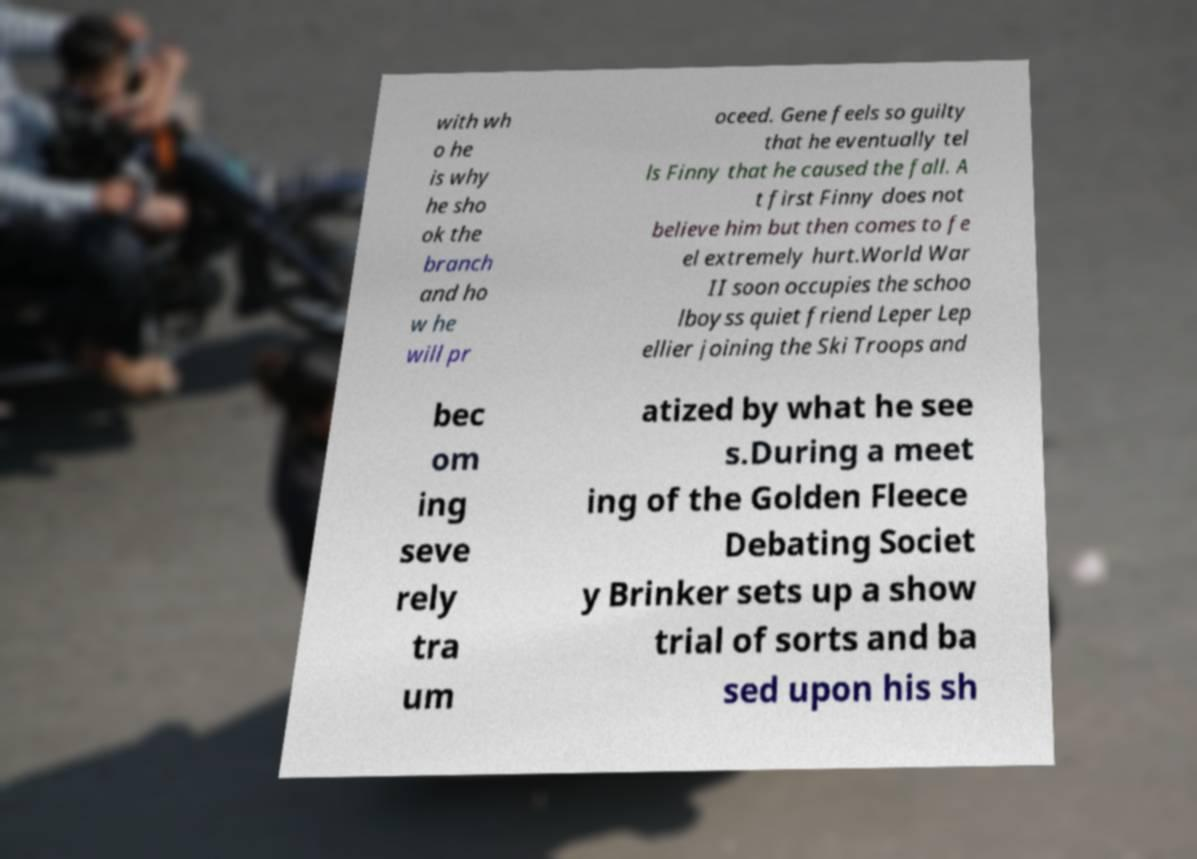There's text embedded in this image that I need extracted. Can you transcribe it verbatim? with wh o he is why he sho ok the branch and ho w he will pr oceed. Gene feels so guilty that he eventually tel ls Finny that he caused the fall. A t first Finny does not believe him but then comes to fe el extremely hurt.World War II soon occupies the schoo lboyss quiet friend Leper Lep ellier joining the Ski Troops and bec om ing seve rely tra um atized by what he see s.During a meet ing of the Golden Fleece Debating Societ y Brinker sets up a show trial of sorts and ba sed upon his sh 